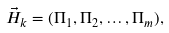Convert formula to latex. <formula><loc_0><loc_0><loc_500><loc_500>\vec { H } _ { k } = ( \Pi _ { 1 } , \Pi _ { 2 } , \dots , \Pi _ { m } ) ,</formula> 